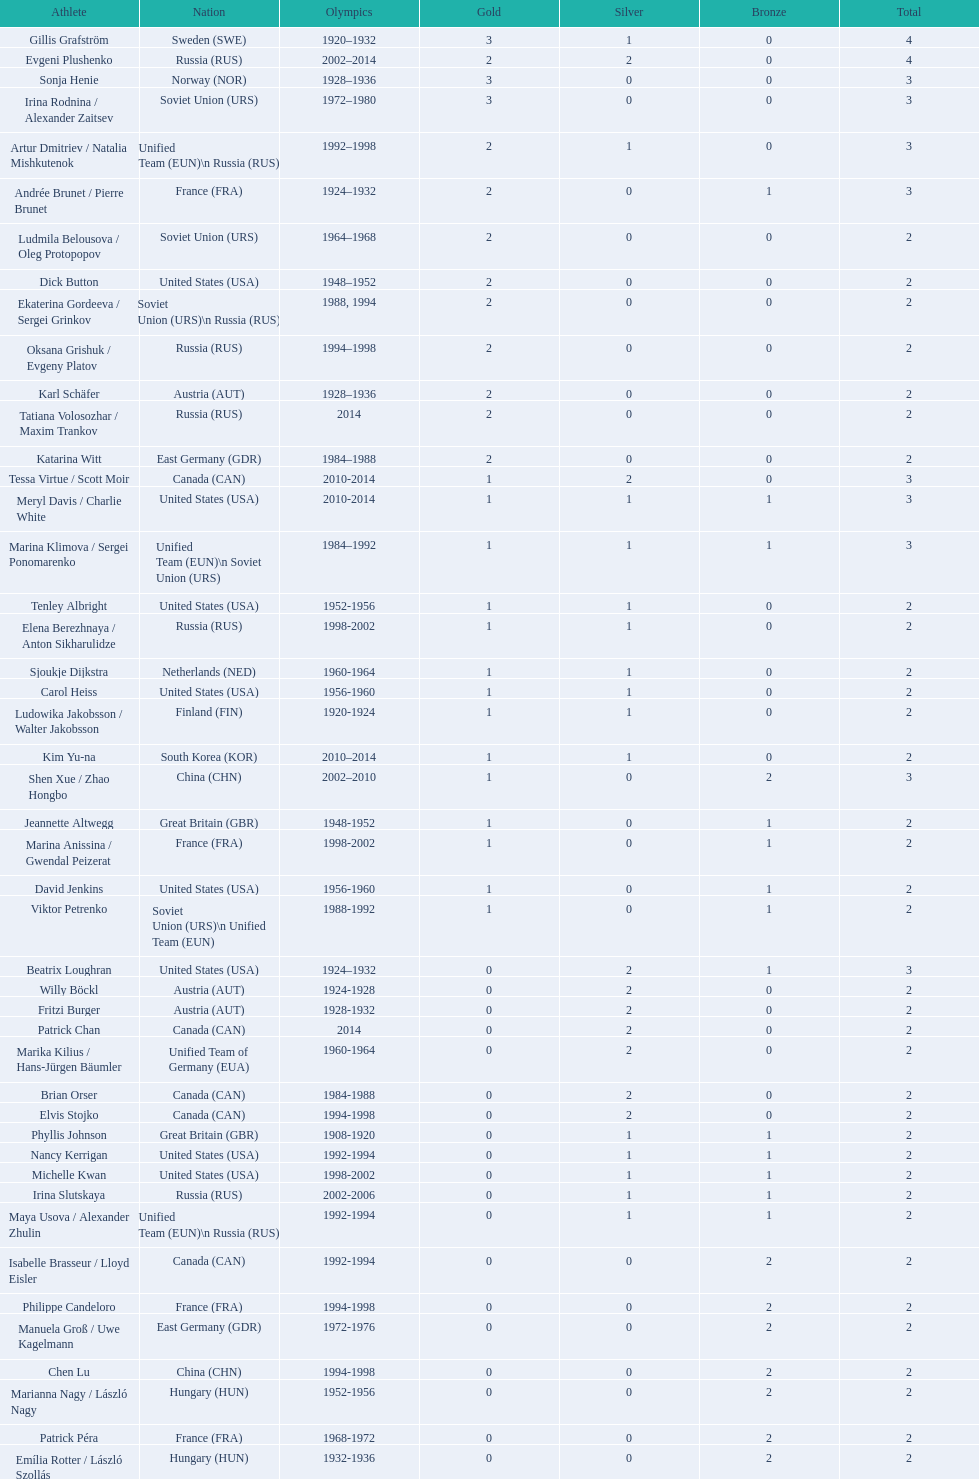In women's figure skating, how many medals has the united states secured overall? 16. 